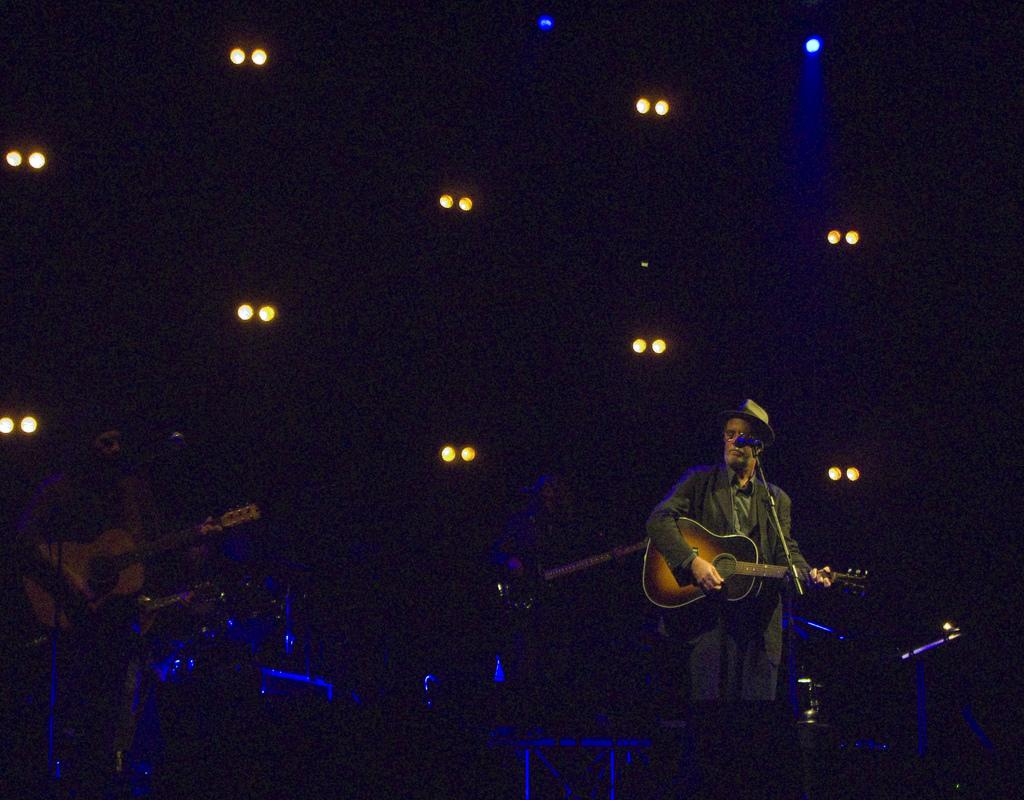How many people are in the image? There are two people in the image. What are the people doing in the image? One person is holding a guitar, and the other person is playing a guitar. What object is in front of the people? There is a microphone in front of the people. What type of shock can be seen affecting the people in the image? There is no shock present in the image; the people are simply holding and playing a guitar. What kind of error is visible in the image? There is no error present in the image; the people are performing a normal activity. 